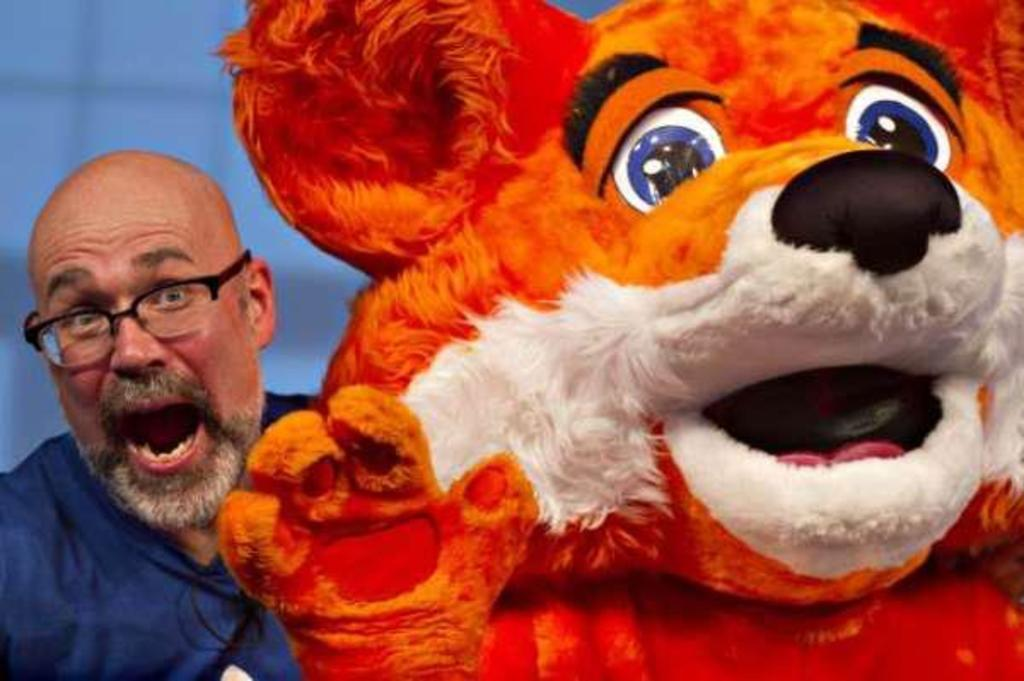Who or what can be seen in the image? There is a person and another person in a costume in the image. What can be observed about the background of the image? The background of the image appears to be blue. Can you describe the setting of the image? The image may have been taken on a stage. Can you see any wrens flying along the coast in the image? There are no wrens or coast visible in the image; it features a person and another person in a costume, with a blue background. 